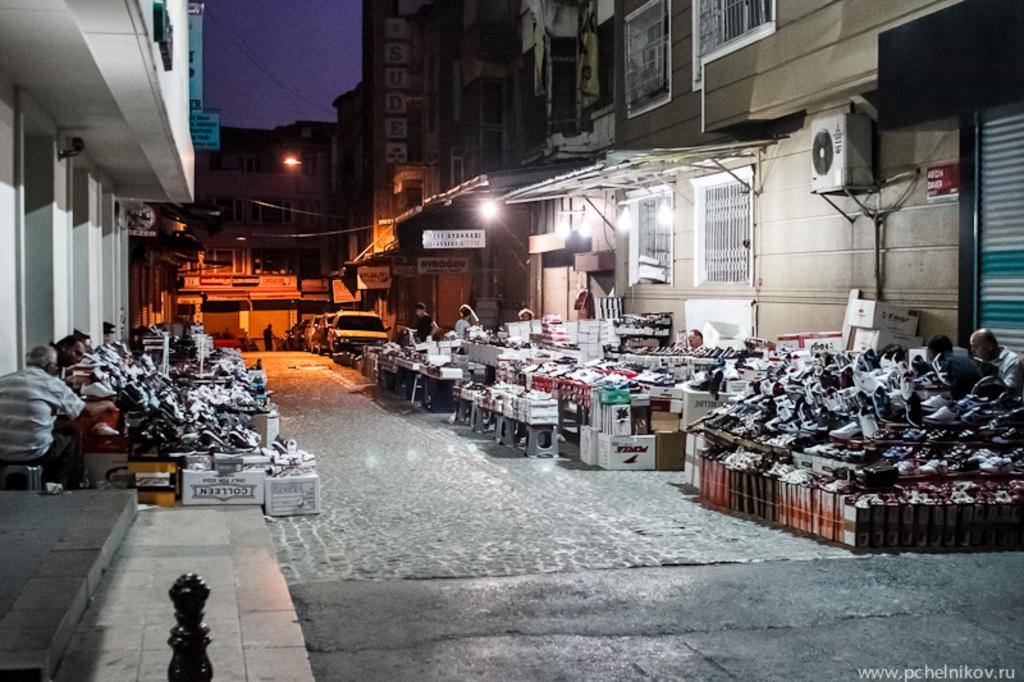What type of structures can be seen in the image? There are buildings in the image. What type of business is visible in the image? There are open footwear stores in the image. What are some of the activities people are engaged in within the image? People are seated and standing in the image. What mode of transportation can be seen in the image? Cars are parked in the image. Where is the tub located in the image? There is no tub present in the image. What type of cake is being served in the image? There is no cake present in the image. 